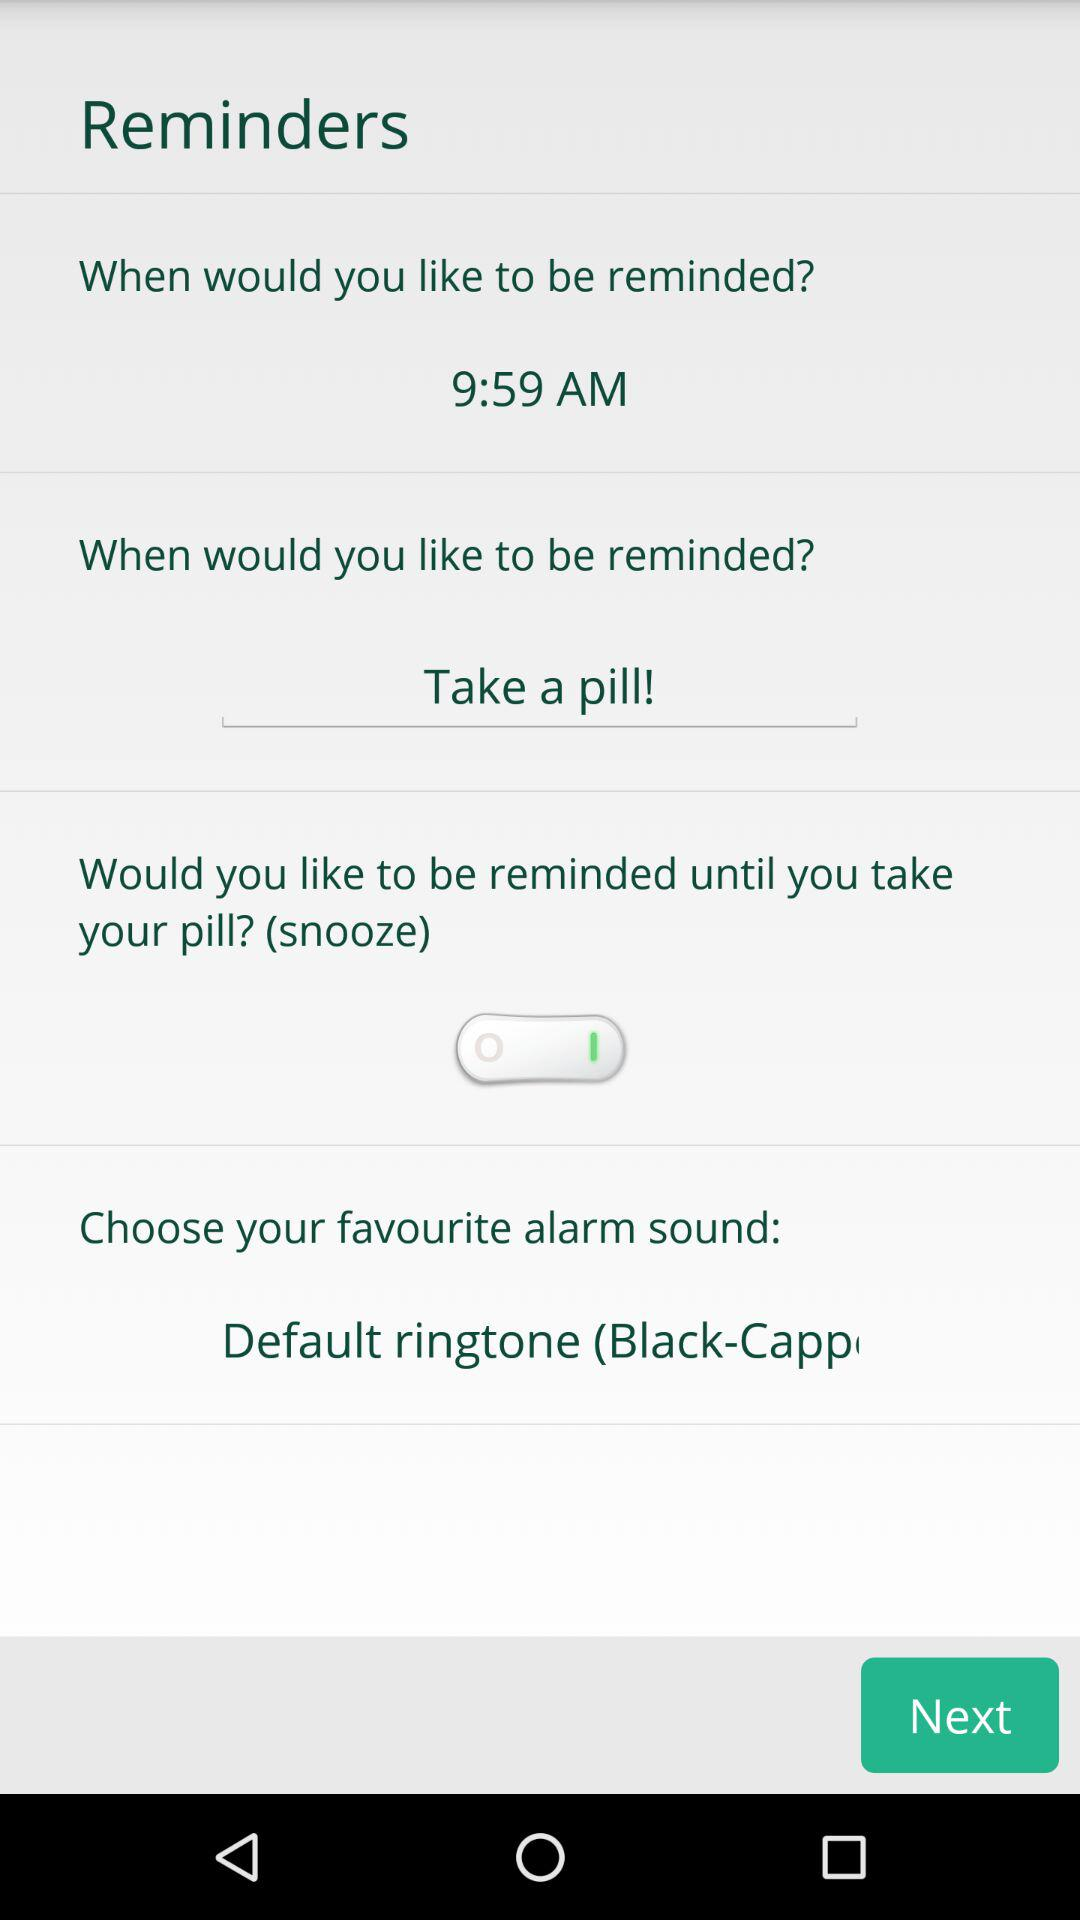At what time should I be reminded? You should be reminded at 9:59 AM. 